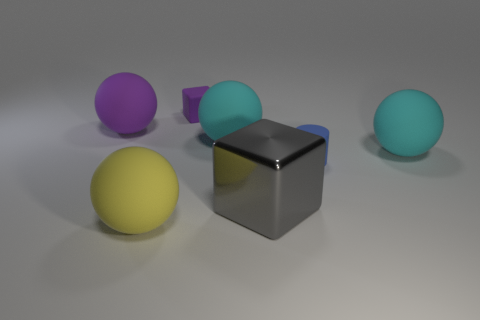Is there anything else that has the same material as the gray block?
Your response must be concise. No. Is there any other thing that is the same shape as the blue object?
Your response must be concise. No. What number of big matte objects are the same color as the matte cube?
Your answer should be compact. 1. Is there a matte thing of the same shape as the large gray metallic object?
Keep it short and to the point. Yes. Is the shape of the big gray object the same as the tiny purple thing?
Offer a terse response. Yes. The rubber sphere that is to the right of the large gray metal object that is behind the big yellow rubber object is what color?
Your answer should be very brief. Cyan. What is the color of the block that is the same size as the blue rubber cylinder?
Provide a short and direct response. Purple. What number of shiny objects are large yellow things or cylinders?
Your answer should be compact. 0. There is a tiny matte object that is in front of the tiny cube; how many cyan objects are to the right of it?
Give a very brief answer. 1. There is a sphere that is the same color as the tiny matte block; what is its size?
Your answer should be compact. Large. 